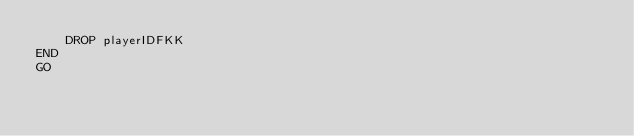Convert code to text. <code><loc_0><loc_0><loc_500><loc_500><_SQL_>	DROP playerIDFKK
END
GO
	</code> 